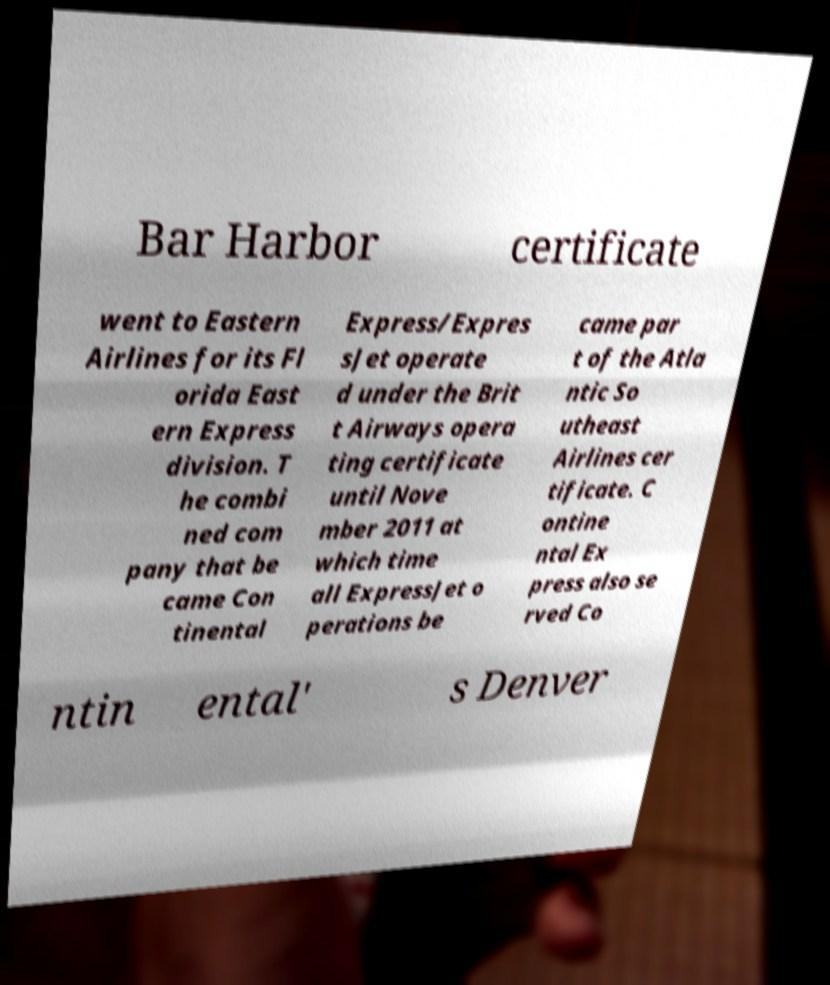Could you assist in decoding the text presented in this image and type it out clearly? Bar Harbor certificate went to Eastern Airlines for its Fl orida East ern Express division. T he combi ned com pany that be came Con tinental Express/Expres sJet operate d under the Brit t Airways opera ting certificate until Nove mber 2011 at which time all ExpressJet o perations be came par t of the Atla ntic So utheast Airlines cer tificate. C ontine ntal Ex press also se rved Co ntin ental' s Denver 